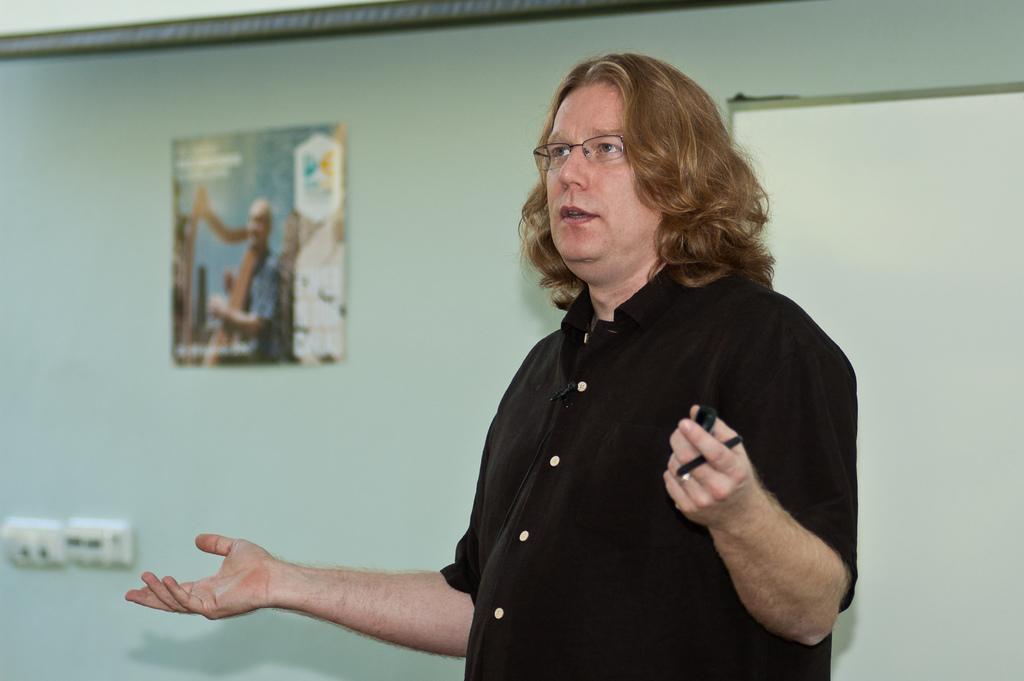Can you describe this image briefly? In this image we can see a man. He is wearing black color shirt and holding pen in his hand. In the background, we can see a white color board and a poster on the wall. There are switchboards on the left side of the image. 